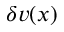<formula> <loc_0><loc_0><loc_500><loc_500>\delta v ( x )</formula> 